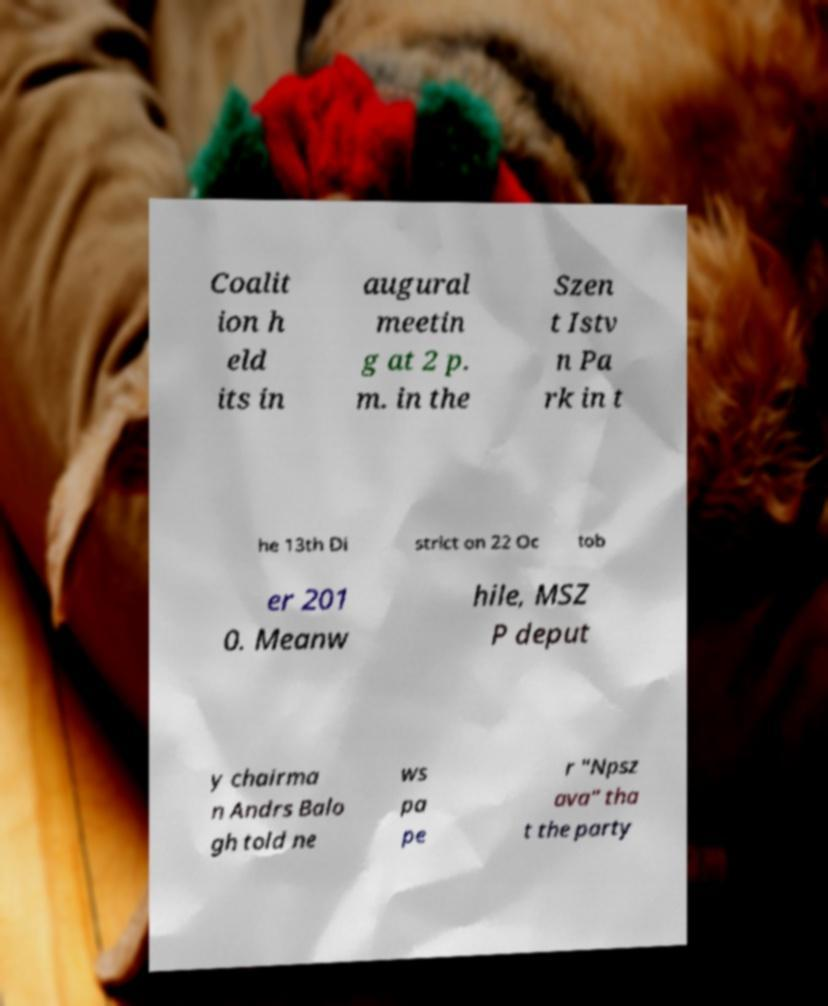There's text embedded in this image that I need extracted. Can you transcribe it verbatim? Coalit ion h eld its in augural meetin g at 2 p. m. in the Szen t Istv n Pa rk in t he 13th Di strict on 22 Oc tob er 201 0. Meanw hile, MSZ P deput y chairma n Andrs Balo gh told ne ws pa pe r "Npsz ava" tha t the party 